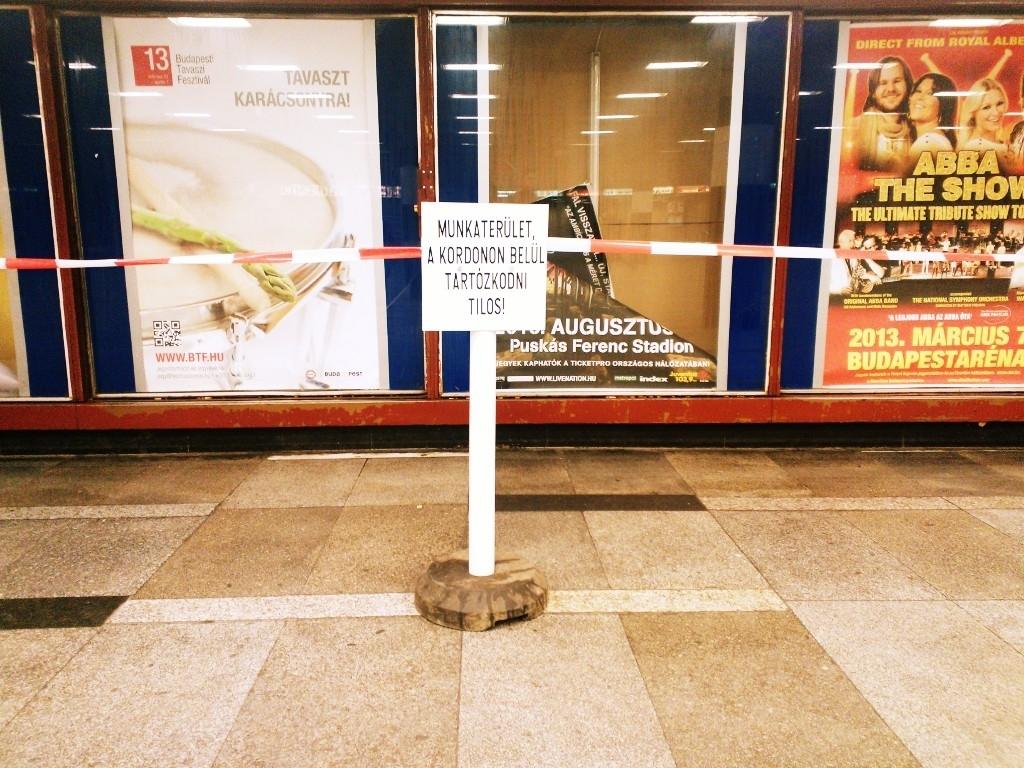What kind of show is featured on the poster on the right?
Offer a terse response. Abba. What year is the show being shown in?
Provide a succinct answer. 2013. 